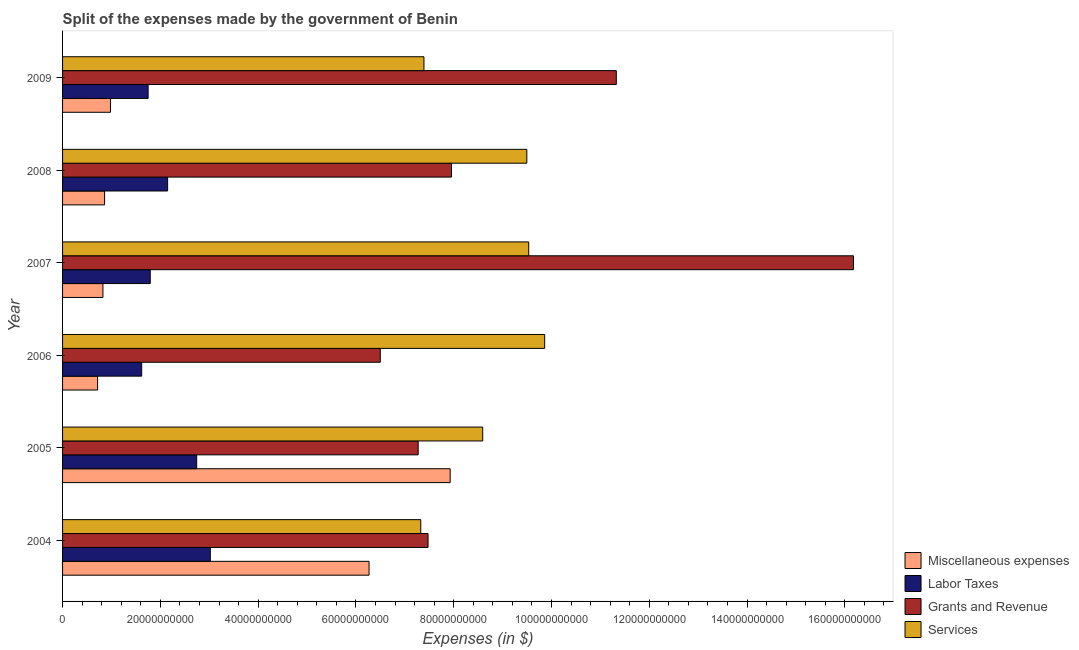How many different coloured bars are there?
Your answer should be compact. 4. Are the number of bars on each tick of the Y-axis equal?
Provide a succinct answer. Yes. What is the label of the 1st group of bars from the top?
Offer a terse response. 2009. What is the amount spent on services in 2005?
Your answer should be compact. 8.59e+1. Across all years, what is the maximum amount spent on labor taxes?
Your response must be concise. 3.02e+1. Across all years, what is the minimum amount spent on labor taxes?
Make the answer very short. 1.62e+1. What is the total amount spent on services in the graph?
Provide a short and direct response. 5.22e+11. What is the difference between the amount spent on miscellaneous expenses in 2006 and that in 2007?
Provide a succinct answer. -1.10e+09. What is the difference between the amount spent on grants and revenue in 2004 and the amount spent on miscellaneous expenses in 2009?
Offer a very short reply. 6.50e+1. What is the average amount spent on miscellaneous expenses per year?
Ensure brevity in your answer.  2.93e+1. In the year 2008, what is the difference between the amount spent on miscellaneous expenses and amount spent on labor taxes?
Provide a succinct answer. -1.29e+1. In how many years, is the amount spent on labor taxes greater than 136000000000 $?
Give a very brief answer. 0. What is the ratio of the amount spent on grants and revenue in 2005 to that in 2008?
Your response must be concise. 0.91. Is the difference between the amount spent on labor taxes in 2004 and 2005 greater than the difference between the amount spent on grants and revenue in 2004 and 2005?
Give a very brief answer. Yes. What is the difference between the highest and the second highest amount spent on grants and revenue?
Offer a terse response. 4.85e+1. What is the difference between the highest and the lowest amount spent on miscellaneous expenses?
Ensure brevity in your answer.  7.21e+1. In how many years, is the amount spent on labor taxes greater than the average amount spent on labor taxes taken over all years?
Offer a very short reply. 2. What does the 2nd bar from the top in 2004 represents?
Ensure brevity in your answer.  Grants and Revenue. What does the 3rd bar from the bottom in 2005 represents?
Your answer should be very brief. Grants and Revenue. Is it the case that in every year, the sum of the amount spent on miscellaneous expenses and amount spent on labor taxes is greater than the amount spent on grants and revenue?
Make the answer very short. No. How many bars are there?
Your answer should be compact. 24. Are the values on the major ticks of X-axis written in scientific E-notation?
Provide a short and direct response. No. Does the graph contain any zero values?
Your answer should be compact. No. Does the graph contain grids?
Ensure brevity in your answer.  No. Where does the legend appear in the graph?
Offer a very short reply. Bottom right. How many legend labels are there?
Make the answer very short. 4. What is the title of the graph?
Provide a short and direct response. Split of the expenses made by the government of Benin. What is the label or title of the X-axis?
Your response must be concise. Expenses (in $). What is the label or title of the Y-axis?
Your answer should be very brief. Year. What is the Expenses (in $) of Miscellaneous expenses in 2004?
Keep it short and to the point. 6.27e+1. What is the Expenses (in $) of Labor Taxes in 2004?
Offer a very short reply. 3.02e+1. What is the Expenses (in $) in Grants and Revenue in 2004?
Give a very brief answer. 7.48e+1. What is the Expenses (in $) of Services in 2004?
Provide a short and direct response. 7.33e+1. What is the Expenses (in $) of Miscellaneous expenses in 2005?
Your response must be concise. 7.93e+1. What is the Expenses (in $) in Labor Taxes in 2005?
Your response must be concise. 2.74e+1. What is the Expenses (in $) of Grants and Revenue in 2005?
Give a very brief answer. 7.27e+1. What is the Expenses (in $) in Services in 2005?
Make the answer very short. 8.59e+1. What is the Expenses (in $) of Miscellaneous expenses in 2006?
Provide a succinct answer. 7.16e+09. What is the Expenses (in $) of Labor Taxes in 2006?
Give a very brief answer. 1.62e+1. What is the Expenses (in $) of Grants and Revenue in 2006?
Make the answer very short. 6.50e+1. What is the Expenses (in $) of Services in 2006?
Provide a succinct answer. 9.86e+1. What is the Expenses (in $) of Miscellaneous expenses in 2007?
Provide a succinct answer. 8.26e+09. What is the Expenses (in $) of Labor Taxes in 2007?
Your response must be concise. 1.79e+1. What is the Expenses (in $) in Grants and Revenue in 2007?
Provide a short and direct response. 1.62e+11. What is the Expenses (in $) in Services in 2007?
Your answer should be compact. 9.53e+1. What is the Expenses (in $) of Miscellaneous expenses in 2008?
Provide a short and direct response. 8.59e+09. What is the Expenses (in $) in Labor Taxes in 2008?
Keep it short and to the point. 2.15e+1. What is the Expenses (in $) in Grants and Revenue in 2008?
Ensure brevity in your answer.  7.96e+1. What is the Expenses (in $) of Services in 2008?
Offer a very short reply. 9.50e+1. What is the Expenses (in $) of Miscellaneous expenses in 2009?
Make the answer very short. 9.79e+09. What is the Expenses (in $) of Labor Taxes in 2009?
Ensure brevity in your answer.  1.75e+1. What is the Expenses (in $) of Grants and Revenue in 2009?
Your response must be concise. 1.13e+11. What is the Expenses (in $) in Services in 2009?
Provide a succinct answer. 7.39e+1. Across all years, what is the maximum Expenses (in $) in Miscellaneous expenses?
Make the answer very short. 7.93e+1. Across all years, what is the maximum Expenses (in $) in Labor Taxes?
Ensure brevity in your answer.  3.02e+1. Across all years, what is the maximum Expenses (in $) of Grants and Revenue?
Give a very brief answer. 1.62e+11. Across all years, what is the maximum Expenses (in $) of Services?
Your answer should be very brief. 9.86e+1. Across all years, what is the minimum Expenses (in $) in Miscellaneous expenses?
Your response must be concise. 7.16e+09. Across all years, what is the minimum Expenses (in $) of Labor Taxes?
Keep it short and to the point. 1.62e+1. Across all years, what is the minimum Expenses (in $) of Grants and Revenue?
Your answer should be very brief. 6.50e+1. Across all years, what is the minimum Expenses (in $) in Services?
Keep it short and to the point. 7.33e+1. What is the total Expenses (in $) of Miscellaneous expenses in the graph?
Offer a terse response. 1.76e+11. What is the total Expenses (in $) of Labor Taxes in the graph?
Provide a short and direct response. 1.31e+11. What is the total Expenses (in $) in Grants and Revenue in the graph?
Provide a short and direct response. 5.67e+11. What is the total Expenses (in $) in Services in the graph?
Your answer should be very brief. 5.22e+11. What is the difference between the Expenses (in $) in Miscellaneous expenses in 2004 and that in 2005?
Your answer should be compact. -1.66e+1. What is the difference between the Expenses (in $) in Labor Taxes in 2004 and that in 2005?
Offer a terse response. 2.79e+09. What is the difference between the Expenses (in $) in Grants and Revenue in 2004 and that in 2005?
Give a very brief answer. 2.02e+09. What is the difference between the Expenses (in $) in Services in 2004 and that in 2005?
Your response must be concise. -1.27e+1. What is the difference between the Expenses (in $) in Miscellaneous expenses in 2004 and that in 2006?
Make the answer very short. 5.55e+1. What is the difference between the Expenses (in $) of Labor Taxes in 2004 and that in 2006?
Your response must be concise. 1.40e+1. What is the difference between the Expenses (in $) in Grants and Revenue in 2004 and that in 2006?
Offer a very short reply. 9.78e+09. What is the difference between the Expenses (in $) in Services in 2004 and that in 2006?
Make the answer very short. -2.53e+1. What is the difference between the Expenses (in $) of Miscellaneous expenses in 2004 and that in 2007?
Your answer should be compact. 5.44e+1. What is the difference between the Expenses (in $) in Labor Taxes in 2004 and that in 2007?
Ensure brevity in your answer.  1.23e+1. What is the difference between the Expenses (in $) in Grants and Revenue in 2004 and that in 2007?
Ensure brevity in your answer.  -8.70e+1. What is the difference between the Expenses (in $) in Services in 2004 and that in 2007?
Offer a very short reply. -2.21e+1. What is the difference between the Expenses (in $) of Miscellaneous expenses in 2004 and that in 2008?
Offer a very short reply. 5.41e+1. What is the difference between the Expenses (in $) in Labor Taxes in 2004 and that in 2008?
Your answer should be compact. 8.73e+09. What is the difference between the Expenses (in $) in Grants and Revenue in 2004 and that in 2008?
Make the answer very short. -4.80e+09. What is the difference between the Expenses (in $) in Services in 2004 and that in 2008?
Your answer should be very brief. -2.17e+1. What is the difference between the Expenses (in $) of Miscellaneous expenses in 2004 and that in 2009?
Offer a terse response. 5.29e+1. What is the difference between the Expenses (in $) in Labor Taxes in 2004 and that in 2009?
Your response must be concise. 1.27e+1. What is the difference between the Expenses (in $) in Grants and Revenue in 2004 and that in 2009?
Provide a succinct answer. -3.85e+1. What is the difference between the Expenses (in $) of Services in 2004 and that in 2009?
Keep it short and to the point. -6.52e+08. What is the difference between the Expenses (in $) of Miscellaneous expenses in 2005 and that in 2006?
Ensure brevity in your answer.  7.21e+1. What is the difference between the Expenses (in $) of Labor Taxes in 2005 and that in 2006?
Offer a very short reply. 1.13e+1. What is the difference between the Expenses (in $) in Grants and Revenue in 2005 and that in 2006?
Ensure brevity in your answer.  7.75e+09. What is the difference between the Expenses (in $) of Services in 2005 and that in 2006?
Provide a short and direct response. -1.27e+1. What is the difference between the Expenses (in $) in Miscellaneous expenses in 2005 and that in 2007?
Keep it short and to the point. 7.10e+1. What is the difference between the Expenses (in $) in Labor Taxes in 2005 and that in 2007?
Make the answer very short. 9.50e+09. What is the difference between the Expenses (in $) in Grants and Revenue in 2005 and that in 2007?
Provide a succinct answer. -8.90e+1. What is the difference between the Expenses (in $) of Services in 2005 and that in 2007?
Your response must be concise. -9.41e+09. What is the difference between the Expenses (in $) of Miscellaneous expenses in 2005 and that in 2008?
Provide a short and direct response. 7.07e+1. What is the difference between the Expenses (in $) in Labor Taxes in 2005 and that in 2008?
Give a very brief answer. 5.94e+09. What is the difference between the Expenses (in $) in Grants and Revenue in 2005 and that in 2008?
Keep it short and to the point. -6.82e+09. What is the difference between the Expenses (in $) of Services in 2005 and that in 2008?
Make the answer very short. -9.02e+09. What is the difference between the Expenses (in $) of Miscellaneous expenses in 2005 and that in 2009?
Make the answer very short. 6.95e+1. What is the difference between the Expenses (in $) of Labor Taxes in 2005 and that in 2009?
Offer a very short reply. 9.93e+09. What is the difference between the Expenses (in $) of Grants and Revenue in 2005 and that in 2009?
Provide a short and direct response. -4.05e+1. What is the difference between the Expenses (in $) of Services in 2005 and that in 2009?
Offer a very short reply. 1.20e+1. What is the difference between the Expenses (in $) in Miscellaneous expenses in 2006 and that in 2007?
Offer a terse response. -1.10e+09. What is the difference between the Expenses (in $) of Labor Taxes in 2006 and that in 2007?
Your response must be concise. -1.75e+09. What is the difference between the Expenses (in $) in Grants and Revenue in 2006 and that in 2007?
Provide a short and direct response. -9.68e+1. What is the difference between the Expenses (in $) in Services in 2006 and that in 2007?
Your answer should be very brief. 3.27e+09. What is the difference between the Expenses (in $) of Miscellaneous expenses in 2006 and that in 2008?
Your answer should be compact. -1.43e+09. What is the difference between the Expenses (in $) in Labor Taxes in 2006 and that in 2008?
Ensure brevity in your answer.  -5.31e+09. What is the difference between the Expenses (in $) of Grants and Revenue in 2006 and that in 2008?
Offer a terse response. -1.46e+1. What is the difference between the Expenses (in $) in Services in 2006 and that in 2008?
Make the answer very short. 3.65e+09. What is the difference between the Expenses (in $) in Miscellaneous expenses in 2006 and that in 2009?
Your answer should be very brief. -2.63e+09. What is the difference between the Expenses (in $) of Labor Taxes in 2006 and that in 2009?
Your answer should be very brief. -1.32e+09. What is the difference between the Expenses (in $) of Grants and Revenue in 2006 and that in 2009?
Provide a short and direct response. -4.83e+1. What is the difference between the Expenses (in $) of Services in 2006 and that in 2009?
Your answer should be very brief. 2.47e+1. What is the difference between the Expenses (in $) of Miscellaneous expenses in 2007 and that in 2008?
Offer a terse response. -3.38e+08. What is the difference between the Expenses (in $) in Labor Taxes in 2007 and that in 2008?
Your answer should be very brief. -3.55e+09. What is the difference between the Expenses (in $) in Grants and Revenue in 2007 and that in 2008?
Offer a terse response. 8.22e+1. What is the difference between the Expenses (in $) of Services in 2007 and that in 2008?
Your response must be concise. 3.85e+08. What is the difference between the Expenses (in $) of Miscellaneous expenses in 2007 and that in 2009?
Your answer should be compact. -1.54e+09. What is the difference between the Expenses (in $) in Labor Taxes in 2007 and that in 2009?
Offer a very short reply. 4.36e+08. What is the difference between the Expenses (in $) in Grants and Revenue in 2007 and that in 2009?
Offer a very short reply. 4.85e+1. What is the difference between the Expenses (in $) in Services in 2007 and that in 2009?
Give a very brief answer. 2.14e+1. What is the difference between the Expenses (in $) in Miscellaneous expenses in 2008 and that in 2009?
Make the answer very short. -1.20e+09. What is the difference between the Expenses (in $) in Labor Taxes in 2008 and that in 2009?
Provide a short and direct response. 3.99e+09. What is the difference between the Expenses (in $) of Grants and Revenue in 2008 and that in 2009?
Keep it short and to the point. -3.37e+1. What is the difference between the Expenses (in $) of Services in 2008 and that in 2009?
Give a very brief answer. 2.10e+1. What is the difference between the Expenses (in $) in Miscellaneous expenses in 2004 and the Expenses (in $) in Labor Taxes in 2005?
Make the answer very short. 3.53e+1. What is the difference between the Expenses (in $) of Miscellaneous expenses in 2004 and the Expenses (in $) of Grants and Revenue in 2005?
Ensure brevity in your answer.  -1.00e+1. What is the difference between the Expenses (in $) in Miscellaneous expenses in 2004 and the Expenses (in $) in Services in 2005?
Your answer should be very brief. -2.32e+1. What is the difference between the Expenses (in $) in Labor Taxes in 2004 and the Expenses (in $) in Grants and Revenue in 2005?
Provide a short and direct response. -4.25e+1. What is the difference between the Expenses (in $) of Labor Taxes in 2004 and the Expenses (in $) of Services in 2005?
Offer a terse response. -5.57e+1. What is the difference between the Expenses (in $) in Grants and Revenue in 2004 and the Expenses (in $) in Services in 2005?
Ensure brevity in your answer.  -1.12e+1. What is the difference between the Expenses (in $) in Miscellaneous expenses in 2004 and the Expenses (in $) in Labor Taxes in 2006?
Keep it short and to the point. 4.65e+1. What is the difference between the Expenses (in $) of Miscellaneous expenses in 2004 and the Expenses (in $) of Grants and Revenue in 2006?
Keep it short and to the point. -2.29e+09. What is the difference between the Expenses (in $) of Miscellaneous expenses in 2004 and the Expenses (in $) of Services in 2006?
Make the answer very short. -3.59e+1. What is the difference between the Expenses (in $) of Labor Taxes in 2004 and the Expenses (in $) of Grants and Revenue in 2006?
Offer a very short reply. -3.48e+1. What is the difference between the Expenses (in $) in Labor Taxes in 2004 and the Expenses (in $) in Services in 2006?
Your answer should be compact. -6.84e+1. What is the difference between the Expenses (in $) of Grants and Revenue in 2004 and the Expenses (in $) of Services in 2006?
Your response must be concise. -2.39e+1. What is the difference between the Expenses (in $) of Miscellaneous expenses in 2004 and the Expenses (in $) of Labor Taxes in 2007?
Offer a very short reply. 4.48e+1. What is the difference between the Expenses (in $) in Miscellaneous expenses in 2004 and the Expenses (in $) in Grants and Revenue in 2007?
Keep it short and to the point. -9.91e+1. What is the difference between the Expenses (in $) of Miscellaneous expenses in 2004 and the Expenses (in $) of Services in 2007?
Your response must be concise. -3.27e+1. What is the difference between the Expenses (in $) in Labor Taxes in 2004 and the Expenses (in $) in Grants and Revenue in 2007?
Your answer should be compact. -1.32e+11. What is the difference between the Expenses (in $) in Labor Taxes in 2004 and the Expenses (in $) in Services in 2007?
Give a very brief answer. -6.51e+1. What is the difference between the Expenses (in $) in Grants and Revenue in 2004 and the Expenses (in $) in Services in 2007?
Keep it short and to the point. -2.06e+1. What is the difference between the Expenses (in $) in Miscellaneous expenses in 2004 and the Expenses (in $) in Labor Taxes in 2008?
Ensure brevity in your answer.  4.12e+1. What is the difference between the Expenses (in $) in Miscellaneous expenses in 2004 and the Expenses (in $) in Grants and Revenue in 2008?
Ensure brevity in your answer.  -1.69e+1. What is the difference between the Expenses (in $) in Miscellaneous expenses in 2004 and the Expenses (in $) in Services in 2008?
Give a very brief answer. -3.23e+1. What is the difference between the Expenses (in $) of Labor Taxes in 2004 and the Expenses (in $) of Grants and Revenue in 2008?
Offer a very short reply. -4.93e+1. What is the difference between the Expenses (in $) in Labor Taxes in 2004 and the Expenses (in $) in Services in 2008?
Provide a short and direct response. -6.47e+1. What is the difference between the Expenses (in $) in Grants and Revenue in 2004 and the Expenses (in $) in Services in 2008?
Your answer should be compact. -2.02e+1. What is the difference between the Expenses (in $) of Miscellaneous expenses in 2004 and the Expenses (in $) of Labor Taxes in 2009?
Keep it short and to the point. 4.52e+1. What is the difference between the Expenses (in $) in Miscellaneous expenses in 2004 and the Expenses (in $) in Grants and Revenue in 2009?
Provide a short and direct response. -5.06e+1. What is the difference between the Expenses (in $) in Miscellaneous expenses in 2004 and the Expenses (in $) in Services in 2009?
Your answer should be very brief. -1.12e+1. What is the difference between the Expenses (in $) of Labor Taxes in 2004 and the Expenses (in $) of Grants and Revenue in 2009?
Offer a terse response. -8.30e+1. What is the difference between the Expenses (in $) of Labor Taxes in 2004 and the Expenses (in $) of Services in 2009?
Offer a terse response. -4.37e+1. What is the difference between the Expenses (in $) of Grants and Revenue in 2004 and the Expenses (in $) of Services in 2009?
Provide a succinct answer. 8.40e+08. What is the difference between the Expenses (in $) of Miscellaneous expenses in 2005 and the Expenses (in $) of Labor Taxes in 2006?
Provide a succinct answer. 6.31e+1. What is the difference between the Expenses (in $) in Miscellaneous expenses in 2005 and the Expenses (in $) in Grants and Revenue in 2006?
Provide a short and direct response. 1.43e+1. What is the difference between the Expenses (in $) of Miscellaneous expenses in 2005 and the Expenses (in $) of Services in 2006?
Provide a succinct answer. -1.93e+1. What is the difference between the Expenses (in $) in Labor Taxes in 2005 and the Expenses (in $) in Grants and Revenue in 2006?
Offer a very short reply. -3.75e+1. What is the difference between the Expenses (in $) in Labor Taxes in 2005 and the Expenses (in $) in Services in 2006?
Offer a very short reply. -7.12e+1. What is the difference between the Expenses (in $) of Grants and Revenue in 2005 and the Expenses (in $) of Services in 2006?
Your answer should be compact. -2.59e+1. What is the difference between the Expenses (in $) in Miscellaneous expenses in 2005 and the Expenses (in $) in Labor Taxes in 2007?
Your response must be concise. 6.13e+1. What is the difference between the Expenses (in $) of Miscellaneous expenses in 2005 and the Expenses (in $) of Grants and Revenue in 2007?
Ensure brevity in your answer.  -8.25e+1. What is the difference between the Expenses (in $) of Miscellaneous expenses in 2005 and the Expenses (in $) of Services in 2007?
Provide a short and direct response. -1.61e+1. What is the difference between the Expenses (in $) of Labor Taxes in 2005 and the Expenses (in $) of Grants and Revenue in 2007?
Ensure brevity in your answer.  -1.34e+11. What is the difference between the Expenses (in $) of Labor Taxes in 2005 and the Expenses (in $) of Services in 2007?
Your response must be concise. -6.79e+1. What is the difference between the Expenses (in $) in Grants and Revenue in 2005 and the Expenses (in $) in Services in 2007?
Give a very brief answer. -2.26e+1. What is the difference between the Expenses (in $) in Miscellaneous expenses in 2005 and the Expenses (in $) in Labor Taxes in 2008?
Make the answer very short. 5.78e+1. What is the difference between the Expenses (in $) in Miscellaneous expenses in 2005 and the Expenses (in $) in Grants and Revenue in 2008?
Offer a very short reply. -2.72e+08. What is the difference between the Expenses (in $) of Miscellaneous expenses in 2005 and the Expenses (in $) of Services in 2008?
Provide a short and direct response. -1.57e+1. What is the difference between the Expenses (in $) of Labor Taxes in 2005 and the Expenses (in $) of Grants and Revenue in 2008?
Give a very brief answer. -5.21e+1. What is the difference between the Expenses (in $) in Labor Taxes in 2005 and the Expenses (in $) in Services in 2008?
Keep it short and to the point. -6.75e+1. What is the difference between the Expenses (in $) of Grants and Revenue in 2005 and the Expenses (in $) of Services in 2008?
Your response must be concise. -2.22e+1. What is the difference between the Expenses (in $) in Miscellaneous expenses in 2005 and the Expenses (in $) in Labor Taxes in 2009?
Your answer should be compact. 6.18e+1. What is the difference between the Expenses (in $) in Miscellaneous expenses in 2005 and the Expenses (in $) in Grants and Revenue in 2009?
Your answer should be very brief. -3.40e+1. What is the difference between the Expenses (in $) in Miscellaneous expenses in 2005 and the Expenses (in $) in Services in 2009?
Your answer should be very brief. 5.36e+09. What is the difference between the Expenses (in $) of Labor Taxes in 2005 and the Expenses (in $) of Grants and Revenue in 2009?
Ensure brevity in your answer.  -8.58e+1. What is the difference between the Expenses (in $) in Labor Taxes in 2005 and the Expenses (in $) in Services in 2009?
Ensure brevity in your answer.  -4.65e+1. What is the difference between the Expenses (in $) of Grants and Revenue in 2005 and the Expenses (in $) of Services in 2009?
Provide a succinct answer. -1.18e+09. What is the difference between the Expenses (in $) in Miscellaneous expenses in 2006 and the Expenses (in $) in Labor Taxes in 2007?
Your answer should be compact. -1.08e+1. What is the difference between the Expenses (in $) in Miscellaneous expenses in 2006 and the Expenses (in $) in Grants and Revenue in 2007?
Keep it short and to the point. -1.55e+11. What is the difference between the Expenses (in $) of Miscellaneous expenses in 2006 and the Expenses (in $) of Services in 2007?
Your answer should be compact. -8.82e+1. What is the difference between the Expenses (in $) in Labor Taxes in 2006 and the Expenses (in $) in Grants and Revenue in 2007?
Offer a very short reply. -1.46e+11. What is the difference between the Expenses (in $) in Labor Taxes in 2006 and the Expenses (in $) in Services in 2007?
Ensure brevity in your answer.  -7.92e+1. What is the difference between the Expenses (in $) of Grants and Revenue in 2006 and the Expenses (in $) of Services in 2007?
Provide a short and direct response. -3.04e+1. What is the difference between the Expenses (in $) of Miscellaneous expenses in 2006 and the Expenses (in $) of Labor Taxes in 2008?
Your answer should be compact. -1.43e+1. What is the difference between the Expenses (in $) in Miscellaneous expenses in 2006 and the Expenses (in $) in Grants and Revenue in 2008?
Provide a short and direct response. -7.24e+1. What is the difference between the Expenses (in $) of Miscellaneous expenses in 2006 and the Expenses (in $) of Services in 2008?
Ensure brevity in your answer.  -8.78e+1. What is the difference between the Expenses (in $) in Labor Taxes in 2006 and the Expenses (in $) in Grants and Revenue in 2008?
Offer a terse response. -6.34e+1. What is the difference between the Expenses (in $) of Labor Taxes in 2006 and the Expenses (in $) of Services in 2008?
Ensure brevity in your answer.  -7.88e+1. What is the difference between the Expenses (in $) of Grants and Revenue in 2006 and the Expenses (in $) of Services in 2008?
Your answer should be compact. -3.00e+1. What is the difference between the Expenses (in $) in Miscellaneous expenses in 2006 and the Expenses (in $) in Labor Taxes in 2009?
Provide a succinct answer. -1.03e+1. What is the difference between the Expenses (in $) in Miscellaneous expenses in 2006 and the Expenses (in $) in Grants and Revenue in 2009?
Your answer should be compact. -1.06e+11. What is the difference between the Expenses (in $) of Miscellaneous expenses in 2006 and the Expenses (in $) of Services in 2009?
Offer a very short reply. -6.68e+1. What is the difference between the Expenses (in $) in Labor Taxes in 2006 and the Expenses (in $) in Grants and Revenue in 2009?
Offer a terse response. -9.71e+1. What is the difference between the Expenses (in $) in Labor Taxes in 2006 and the Expenses (in $) in Services in 2009?
Keep it short and to the point. -5.77e+1. What is the difference between the Expenses (in $) in Grants and Revenue in 2006 and the Expenses (in $) in Services in 2009?
Provide a succinct answer. -8.94e+09. What is the difference between the Expenses (in $) in Miscellaneous expenses in 2007 and the Expenses (in $) in Labor Taxes in 2008?
Provide a succinct answer. -1.32e+1. What is the difference between the Expenses (in $) in Miscellaneous expenses in 2007 and the Expenses (in $) in Grants and Revenue in 2008?
Your answer should be very brief. -7.13e+1. What is the difference between the Expenses (in $) of Miscellaneous expenses in 2007 and the Expenses (in $) of Services in 2008?
Keep it short and to the point. -8.67e+1. What is the difference between the Expenses (in $) of Labor Taxes in 2007 and the Expenses (in $) of Grants and Revenue in 2008?
Make the answer very short. -6.16e+1. What is the difference between the Expenses (in $) in Labor Taxes in 2007 and the Expenses (in $) in Services in 2008?
Your answer should be compact. -7.70e+1. What is the difference between the Expenses (in $) in Grants and Revenue in 2007 and the Expenses (in $) in Services in 2008?
Offer a very short reply. 6.68e+1. What is the difference between the Expenses (in $) in Miscellaneous expenses in 2007 and the Expenses (in $) in Labor Taxes in 2009?
Your answer should be compact. -9.24e+09. What is the difference between the Expenses (in $) in Miscellaneous expenses in 2007 and the Expenses (in $) in Grants and Revenue in 2009?
Your answer should be compact. -1.05e+11. What is the difference between the Expenses (in $) in Miscellaneous expenses in 2007 and the Expenses (in $) in Services in 2009?
Keep it short and to the point. -6.57e+1. What is the difference between the Expenses (in $) in Labor Taxes in 2007 and the Expenses (in $) in Grants and Revenue in 2009?
Offer a terse response. -9.53e+1. What is the difference between the Expenses (in $) in Labor Taxes in 2007 and the Expenses (in $) in Services in 2009?
Make the answer very short. -5.60e+1. What is the difference between the Expenses (in $) of Grants and Revenue in 2007 and the Expenses (in $) of Services in 2009?
Keep it short and to the point. 8.79e+1. What is the difference between the Expenses (in $) of Miscellaneous expenses in 2008 and the Expenses (in $) of Labor Taxes in 2009?
Keep it short and to the point. -8.90e+09. What is the difference between the Expenses (in $) of Miscellaneous expenses in 2008 and the Expenses (in $) of Grants and Revenue in 2009?
Offer a terse response. -1.05e+11. What is the difference between the Expenses (in $) in Miscellaneous expenses in 2008 and the Expenses (in $) in Services in 2009?
Offer a terse response. -6.53e+1. What is the difference between the Expenses (in $) of Labor Taxes in 2008 and the Expenses (in $) of Grants and Revenue in 2009?
Keep it short and to the point. -9.18e+1. What is the difference between the Expenses (in $) of Labor Taxes in 2008 and the Expenses (in $) of Services in 2009?
Offer a very short reply. -5.24e+1. What is the difference between the Expenses (in $) in Grants and Revenue in 2008 and the Expenses (in $) in Services in 2009?
Make the answer very short. 5.64e+09. What is the average Expenses (in $) of Miscellaneous expenses per year?
Your response must be concise. 2.93e+1. What is the average Expenses (in $) in Labor Taxes per year?
Keep it short and to the point. 2.18e+1. What is the average Expenses (in $) of Grants and Revenue per year?
Offer a terse response. 9.45e+1. What is the average Expenses (in $) of Services per year?
Ensure brevity in your answer.  8.70e+1. In the year 2004, what is the difference between the Expenses (in $) in Miscellaneous expenses and Expenses (in $) in Labor Taxes?
Your response must be concise. 3.25e+1. In the year 2004, what is the difference between the Expenses (in $) of Miscellaneous expenses and Expenses (in $) of Grants and Revenue?
Make the answer very short. -1.21e+1. In the year 2004, what is the difference between the Expenses (in $) in Miscellaneous expenses and Expenses (in $) in Services?
Offer a very short reply. -1.06e+1. In the year 2004, what is the difference between the Expenses (in $) of Labor Taxes and Expenses (in $) of Grants and Revenue?
Make the answer very short. -4.45e+1. In the year 2004, what is the difference between the Expenses (in $) of Labor Taxes and Expenses (in $) of Services?
Provide a short and direct response. -4.30e+1. In the year 2004, what is the difference between the Expenses (in $) of Grants and Revenue and Expenses (in $) of Services?
Your answer should be very brief. 1.49e+09. In the year 2005, what is the difference between the Expenses (in $) of Miscellaneous expenses and Expenses (in $) of Labor Taxes?
Provide a short and direct response. 5.18e+1. In the year 2005, what is the difference between the Expenses (in $) in Miscellaneous expenses and Expenses (in $) in Grants and Revenue?
Offer a terse response. 6.55e+09. In the year 2005, what is the difference between the Expenses (in $) in Miscellaneous expenses and Expenses (in $) in Services?
Keep it short and to the point. -6.66e+09. In the year 2005, what is the difference between the Expenses (in $) of Labor Taxes and Expenses (in $) of Grants and Revenue?
Give a very brief answer. -4.53e+1. In the year 2005, what is the difference between the Expenses (in $) of Labor Taxes and Expenses (in $) of Services?
Make the answer very short. -5.85e+1. In the year 2005, what is the difference between the Expenses (in $) in Grants and Revenue and Expenses (in $) in Services?
Give a very brief answer. -1.32e+1. In the year 2006, what is the difference between the Expenses (in $) in Miscellaneous expenses and Expenses (in $) in Labor Taxes?
Offer a very short reply. -9.02e+09. In the year 2006, what is the difference between the Expenses (in $) in Miscellaneous expenses and Expenses (in $) in Grants and Revenue?
Provide a succinct answer. -5.78e+1. In the year 2006, what is the difference between the Expenses (in $) of Miscellaneous expenses and Expenses (in $) of Services?
Offer a very short reply. -9.15e+1. In the year 2006, what is the difference between the Expenses (in $) in Labor Taxes and Expenses (in $) in Grants and Revenue?
Offer a terse response. -4.88e+1. In the year 2006, what is the difference between the Expenses (in $) of Labor Taxes and Expenses (in $) of Services?
Provide a succinct answer. -8.24e+1. In the year 2006, what is the difference between the Expenses (in $) in Grants and Revenue and Expenses (in $) in Services?
Provide a short and direct response. -3.36e+1. In the year 2007, what is the difference between the Expenses (in $) of Miscellaneous expenses and Expenses (in $) of Labor Taxes?
Your response must be concise. -9.68e+09. In the year 2007, what is the difference between the Expenses (in $) of Miscellaneous expenses and Expenses (in $) of Grants and Revenue?
Your answer should be very brief. -1.54e+11. In the year 2007, what is the difference between the Expenses (in $) in Miscellaneous expenses and Expenses (in $) in Services?
Your answer should be compact. -8.71e+1. In the year 2007, what is the difference between the Expenses (in $) of Labor Taxes and Expenses (in $) of Grants and Revenue?
Ensure brevity in your answer.  -1.44e+11. In the year 2007, what is the difference between the Expenses (in $) of Labor Taxes and Expenses (in $) of Services?
Give a very brief answer. -7.74e+1. In the year 2007, what is the difference between the Expenses (in $) in Grants and Revenue and Expenses (in $) in Services?
Offer a very short reply. 6.64e+1. In the year 2008, what is the difference between the Expenses (in $) in Miscellaneous expenses and Expenses (in $) in Labor Taxes?
Keep it short and to the point. -1.29e+1. In the year 2008, what is the difference between the Expenses (in $) of Miscellaneous expenses and Expenses (in $) of Grants and Revenue?
Keep it short and to the point. -7.10e+1. In the year 2008, what is the difference between the Expenses (in $) in Miscellaneous expenses and Expenses (in $) in Services?
Provide a short and direct response. -8.64e+1. In the year 2008, what is the difference between the Expenses (in $) of Labor Taxes and Expenses (in $) of Grants and Revenue?
Provide a succinct answer. -5.81e+1. In the year 2008, what is the difference between the Expenses (in $) of Labor Taxes and Expenses (in $) of Services?
Your response must be concise. -7.35e+1. In the year 2008, what is the difference between the Expenses (in $) in Grants and Revenue and Expenses (in $) in Services?
Keep it short and to the point. -1.54e+1. In the year 2009, what is the difference between the Expenses (in $) in Miscellaneous expenses and Expenses (in $) in Labor Taxes?
Your answer should be very brief. -7.70e+09. In the year 2009, what is the difference between the Expenses (in $) of Miscellaneous expenses and Expenses (in $) of Grants and Revenue?
Provide a succinct answer. -1.03e+11. In the year 2009, what is the difference between the Expenses (in $) of Miscellaneous expenses and Expenses (in $) of Services?
Offer a very short reply. -6.41e+1. In the year 2009, what is the difference between the Expenses (in $) of Labor Taxes and Expenses (in $) of Grants and Revenue?
Your response must be concise. -9.58e+1. In the year 2009, what is the difference between the Expenses (in $) in Labor Taxes and Expenses (in $) in Services?
Offer a terse response. -5.64e+1. In the year 2009, what is the difference between the Expenses (in $) of Grants and Revenue and Expenses (in $) of Services?
Ensure brevity in your answer.  3.93e+1. What is the ratio of the Expenses (in $) in Miscellaneous expenses in 2004 to that in 2005?
Your answer should be very brief. 0.79. What is the ratio of the Expenses (in $) of Labor Taxes in 2004 to that in 2005?
Offer a terse response. 1.1. What is the ratio of the Expenses (in $) of Grants and Revenue in 2004 to that in 2005?
Provide a succinct answer. 1.03. What is the ratio of the Expenses (in $) of Services in 2004 to that in 2005?
Offer a very short reply. 0.85. What is the ratio of the Expenses (in $) of Miscellaneous expenses in 2004 to that in 2006?
Offer a very short reply. 8.76. What is the ratio of the Expenses (in $) of Labor Taxes in 2004 to that in 2006?
Keep it short and to the point. 1.87. What is the ratio of the Expenses (in $) of Grants and Revenue in 2004 to that in 2006?
Your answer should be compact. 1.15. What is the ratio of the Expenses (in $) of Services in 2004 to that in 2006?
Give a very brief answer. 0.74. What is the ratio of the Expenses (in $) in Miscellaneous expenses in 2004 to that in 2007?
Make the answer very short. 7.59. What is the ratio of the Expenses (in $) in Labor Taxes in 2004 to that in 2007?
Make the answer very short. 1.69. What is the ratio of the Expenses (in $) of Grants and Revenue in 2004 to that in 2007?
Your response must be concise. 0.46. What is the ratio of the Expenses (in $) in Services in 2004 to that in 2007?
Provide a succinct answer. 0.77. What is the ratio of the Expenses (in $) of Miscellaneous expenses in 2004 to that in 2008?
Make the answer very short. 7.29. What is the ratio of the Expenses (in $) in Labor Taxes in 2004 to that in 2008?
Offer a terse response. 1.41. What is the ratio of the Expenses (in $) in Grants and Revenue in 2004 to that in 2008?
Give a very brief answer. 0.94. What is the ratio of the Expenses (in $) in Services in 2004 to that in 2008?
Offer a terse response. 0.77. What is the ratio of the Expenses (in $) in Miscellaneous expenses in 2004 to that in 2009?
Provide a succinct answer. 6.4. What is the ratio of the Expenses (in $) of Labor Taxes in 2004 to that in 2009?
Keep it short and to the point. 1.73. What is the ratio of the Expenses (in $) in Grants and Revenue in 2004 to that in 2009?
Ensure brevity in your answer.  0.66. What is the ratio of the Expenses (in $) of Miscellaneous expenses in 2005 to that in 2006?
Offer a very short reply. 11.07. What is the ratio of the Expenses (in $) of Labor Taxes in 2005 to that in 2006?
Your response must be concise. 1.7. What is the ratio of the Expenses (in $) of Grants and Revenue in 2005 to that in 2006?
Your answer should be compact. 1.12. What is the ratio of the Expenses (in $) in Services in 2005 to that in 2006?
Your answer should be very brief. 0.87. What is the ratio of the Expenses (in $) in Miscellaneous expenses in 2005 to that in 2007?
Give a very brief answer. 9.6. What is the ratio of the Expenses (in $) of Labor Taxes in 2005 to that in 2007?
Keep it short and to the point. 1.53. What is the ratio of the Expenses (in $) of Grants and Revenue in 2005 to that in 2007?
Provide a short and direct response. 0.45. What is the ratio of the Expenses (in $) of Services in 2005 to that in 2007?
Your answer should be compact. 0.9. What is the ratio of the Expenses (in $) in Miscellaneous expenses in 2005 to that in 2008?
Offer a very short reply. 9.22. What is the ratio of the Expenses (in $) in Labor Taxes in 2005 to that in 2008?
Give a very brief answer. 1.28. What is the ratio of the Expenses (in $) in Grants and Revenue in 2005 to that in 2008?
Offer a very short reply. 0.91. What is the ratio of the Expenses (in $) in Services in 2005 to that in 2008?
Your response must be concise. 0.91. What is the ratio of the Expenses (in $) of Miscellaneous expenses in 2005 to that in 2009?
Provide a succinct answer. 8.09. What is the ratio of the Expenses (in $) in Labor Taxes in 2005 to that in 2009?
Provide a succinct answer. 1.57. What is the ratio of the Expenses (in $) of Grants and Revenue in 2005 to that in 2009?
Your response must be concise. 0.64. What is the ratio of the Expenses (in $) in Services in 2005 to that in 2009?
Your answer should be very brief. 1.16. What is the ratio of the Expenses (in $) of Miscellaneous expenses in 2006 to that in 2007?
Provide a short and direct response. 0.87. What is the ratio of the Expenses (in $) in Labor Taxes in 2006 to that in 2007?
Offer a terse response. 0.9. What is the ratio of the Expenses (in $) in Grants and Revenue in 2006 to that in 2007?
Make the answer very short. 0.4. What is the ratio of the Expenses (in $) in Services in 2006 to that in 2007?
Your answer should be very brief. 1.03. What is the ratio of the Expenses (in $) in Miscellaneous expenses in 2006 to that in 2008?
Give a very brief answer. 0.83. What is the ratio of the Expenses (in $) in Labor Taxes in 2006 to that in 2008?
Give a very brief answer. 0.75. What is the ratio of the Expenses (in $) in Grants and Revenue in 2006 to that in 2008?
Keep it short and to the point. 0.82. What is the ratio of the Expenses (in $) in Services in 2006 to that in 2008?
Provide a short and direct response. 1.04. What is the ratio of the Expenses (in $) of Miscellaneous expenses in 2006 to that in 2009?
Your answer should be compact. 0.73. What is the ratio of the Expenses (in $) of Labor Taxes in 2006 to that in 2009?
Your answer should be very brief. 0.92. What is the ratio of the Expenses (in $) of Grants and Revenue in 2006 to that in 2009?
Your response must be concise. 0.57. What is the ratio of the Expenses (in $) in Services in 2006 to that in 2009?
Your response must be concise. 1.33. What is the ratio of the Expenses (in $) in Miscellaneous expenses in 2007 to that in 2008?
Your response must be concise. 0.96. What is the ratio of the Expenses (in $) of Labor Taxes in 2007 to that in 2008?
Keep it short and to the point. 0.83. What is the ratio of the Expenses (in $) of Grants and Revenue in 2007 to that in 2008?
Offer a terse response. 2.03. What is the ratio of the Expenses (in $) in Services in 2007 to that in 2008?
Keep it short and to the point. 1. What is the ratio of the Expenses (in $) in Miscellaneous expenses in 2007 to that in 2009?
Your answer should be compact. 0.84. What is the ratio of the Expenses (in $) of Labor Taxes in 2007 to that in 2009?
Make the answer very short. 1.02. What is the ratio of the Expenses (in $) in Grants and Revenue in 2007 to that in 2009?
Provide a short and direct response. 1.43. What is the ratio of the Expenses (in $) in Services in 2007 to that in 2009?
Make the answer very short. 1.29. What is the ratio of the Expenses (in $) in Miscellaneous expenses in 2008 to that in 2009?
Offer a very short reply. 0.88. What is the ratio of the Expenses (in $) in Labor Taxes in 2008 to that in 2009?
Your answer should be compact. 1.23. What is the ratio of the Expenses (in $) in Grants and Revenue in 2008 to that in 2009?
Give a very brief answer. 0.7. What is the ratio of the Expenses (in $) in Services in 2008 to that in 2009?
Provide a short and direct response. 1.28. What is the difference between the highest and the second highest Expenses (in $) of Miscellaneous expenses?
Provide a short and direct response. 1.66e+1. What is the difference between the highest and the second highest Expenses (in $) in Labor Taxes?
Offer a terse response. 2.79e+09. What is the difference between the highest and the second highest Expenses (in $) of Grants and Revenue?
Keep it short and to the point. 4.85e+1. What is the difference between the highest and the second highest Expenses (in $) of Services?
Your response must be concise. 3.27e+09. What is the difference between the highest and the lowest Expenses (in $) of Miscellaneous expenses?
Keep it short and to the point. 7.21e+1. What is the difference between the highest and the lowest Expenses (in $) of Labor Taxes?
Provide a short and direct response. 1.40e+1. What is the difference between the highest and the lowest Expenses (in $) of Grants and Revenue?
Give a very brief answer. 9.68e+1. What is the difference between the highest and the lowest Expenses (in $) of Services?
Keep it short and to the point. 2.53e+1. 